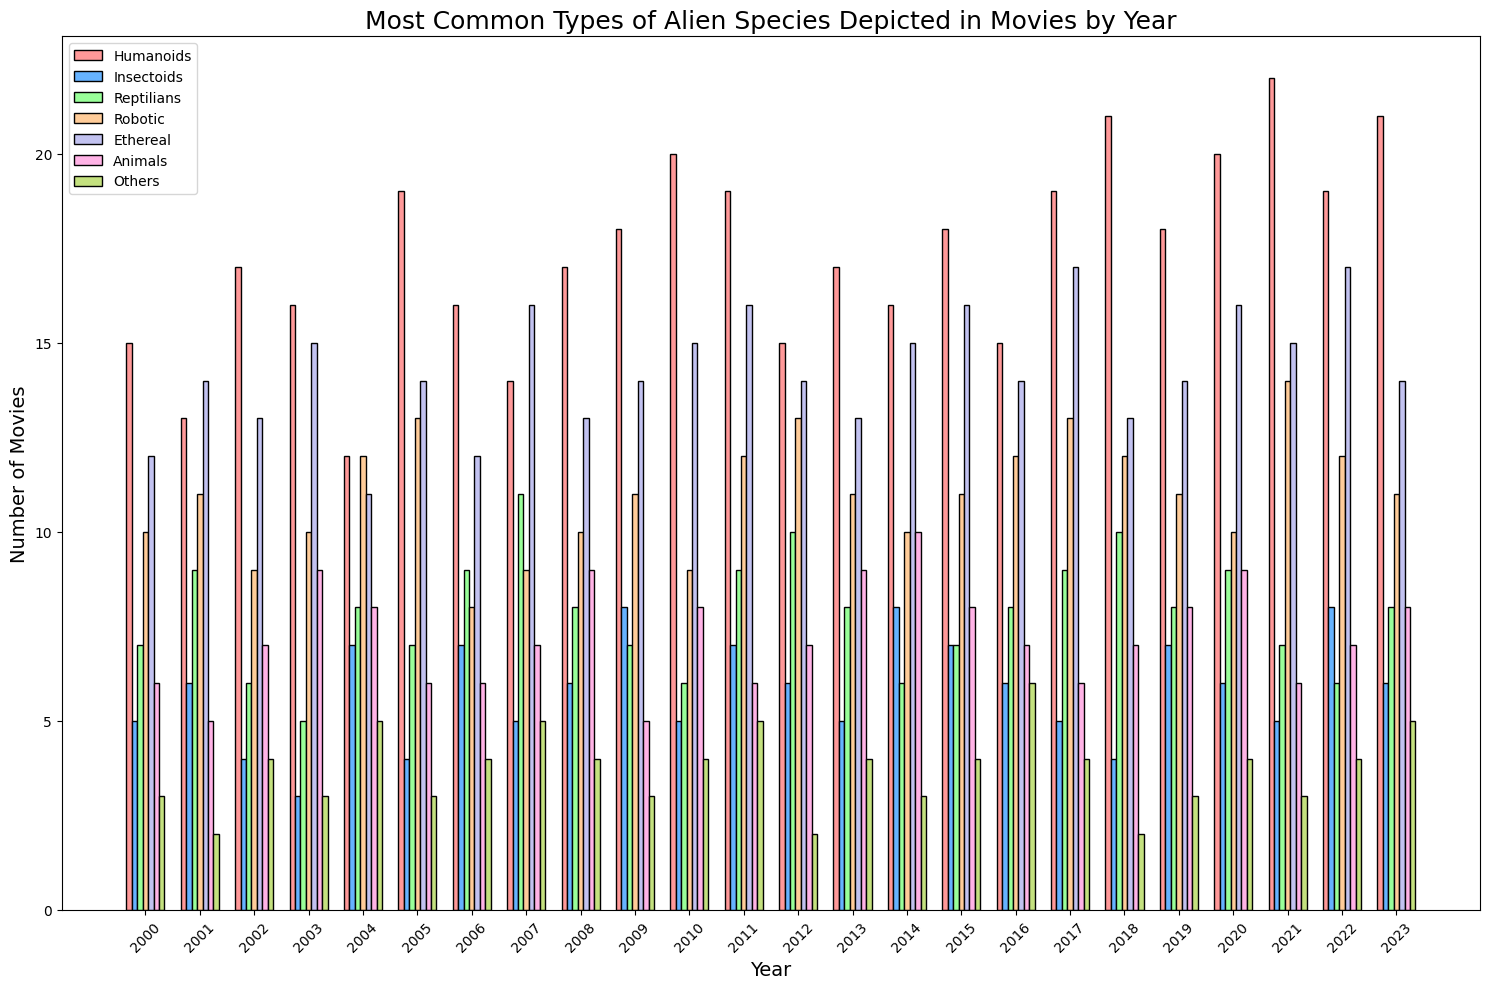what was the most commonly depicted alien species in the year 2000? To find the answer, look at the bars corresponding to the year 2000 and identify the tallest one. The humanoids bar is the tallest.
Answer: Humanoids Which year had the highest number of insectoid alien species depicted in movies? Examine the insectoids bars across all years and identify the tallest one, which corresponds to 2009 and 2022, both having 8.
Answer: 2009 and 2022 For the year 2021, what is the difference between the number of movies featuring humanoid aliens and animal aliens? Locate the bars for humanoids and animals for 2021. Humanoids have 22 and animals have 6. The difference is 22 - 6 = 16.
Answer: 16 In which year did ethereal alien species first surpass 15 movies depicted? Look at the ethereal bars and find the first year where the bar's height exceeds 15. The year is 2007 when it reached 16.
Answer: 2007 What is the trend of robotic alien species appearing in movies from 2019 to 2023? Examine the heights of the robotic bars from 2019 to 2023. The numbers are 11, 10, 14, 12, and 11, indicating a fluctuation without a clear upward or downward trend.
Answer: No clear trend Which alien species saw a peak depiction in the year 2018 and subsequently declined in the following year? Look at each bar in 2018 and compare with 2019. The insectoid bar peaked at 2018 with 10 and declined to 7 in 2019.
Answer: Insectoids What is the total number of movies featuring reptilian aliens in the years 2014 and 2015? Add the number of reptilian alien films for 2014 (6) and 2015 (7). The total is 6 + 7 = 13.
Answer: 13 Between humanoid and ethereal alien species, which had more appearances in movies in 2020? Compare the bar heights for humanoids (20) and ethereal (16) in 2020. Humanoids had more appearances.
Answer: Humanoids What is the average number of movies featuring animal-like alien species from 2015 to 2020? Sum the numbers for animals from 2015 (8), 2016 (7), 2017 (6), 2018 (7), 2019 (8), and 2020 (9). The total is 45 over 6 years. The average is 45/6 = 7.5.
Answer: 7.5 In terms of depiction in movies, which year marks the highest diversity of alien species (considering all categories)? The year with the highest combined bar heights across all categories was 2021, summing each alien group’s count: 22 (humanoids) + 5 (insectoids) + 7 (reptilians) + 14 (robotic) + 15 (ethereal) + 6 (animals) + 3 (others) = 72 movies
Answer: 2021 